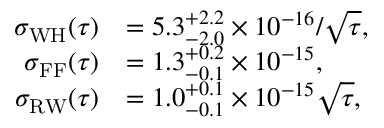Convert formula to latex. <formula><loc_0><loc_0><loc_500><loc_500>\begin{array} { r l } { \sigma _ { W H } ( \tau ) } & { = 5 . 3 _ { - 2 . 0 } ^ { + 2 . 2 } \times 1 0 ^ { - 1 6 } / \sqrt { \tau } , } \\ { \sigma _ { F F } ( \tau ) } & { = 1 . 3 _ { - 0 . 1 } ^ { + 0 . 2 } \times 1 0 ^ { - 1 5 } , } \\ { \sigma _ { R W } ( \tau ) } & { = 1 . 0 _ { - 0 . 1 } ^ { + 0 . 1 } \times 1 0 ^ { - 1 5 } \sqrt { \tau } , } \end{array}</formula> 